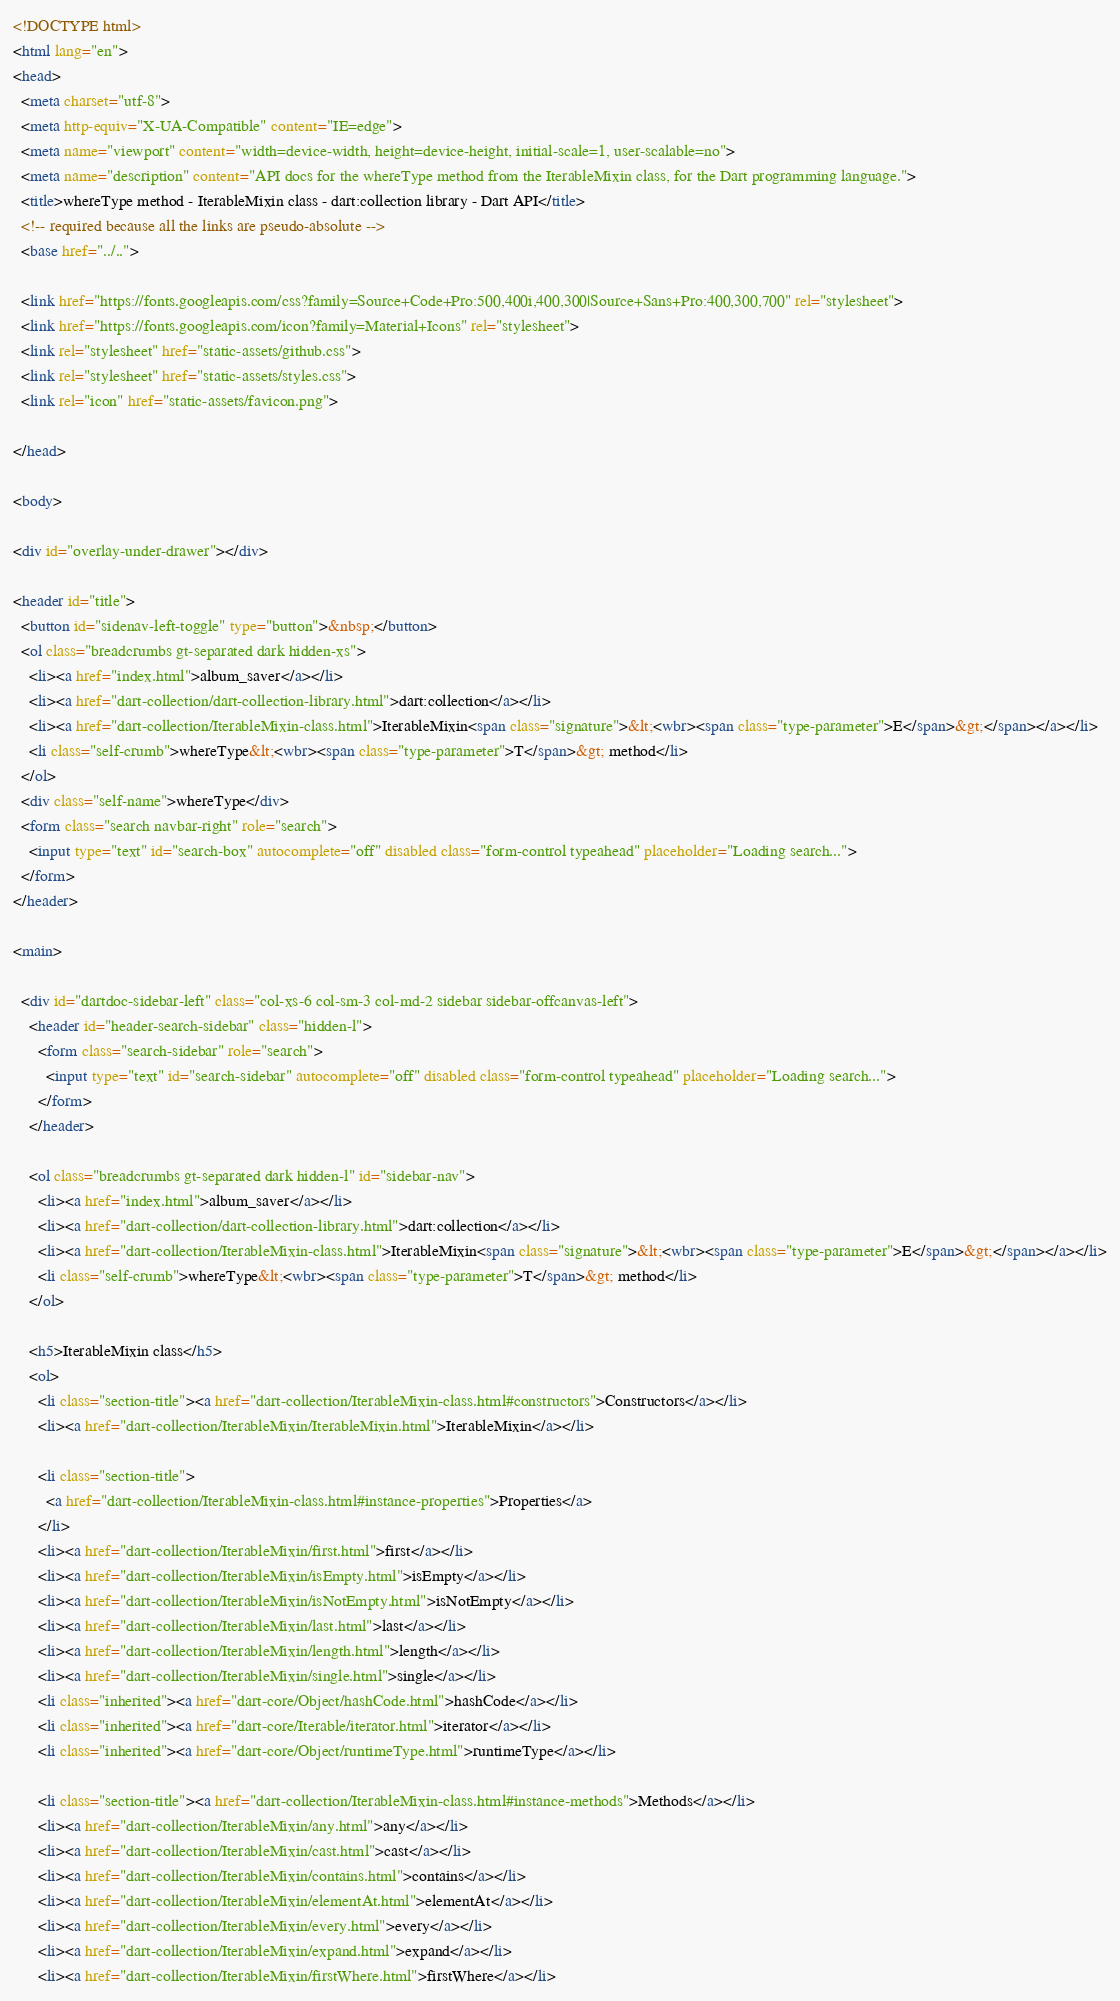<code> <loc_0><loc_0><loc_500><loc_500><_HTML_><!DOCTYPE html>
<html lang="en">
<head>
  <meta charset="utf-8">
  <meta http-equiv="X-UA-Compatible" content="IE=edge">
  <meta name="viewport" content="width=device-width, height=device-height, initial-scale=1, user-scalable=no">
  <meta name="description" content="API docs for the whereType method from the IterableMixin class, for the Dart programming language.">
  <title>whereType method - IterableMixin class - dart:collection library - Dart API</title>
  <!-- required because all the links are pseudo-absolute -->
  <base href="../..">

  <link href="https://fonts.googleapis.com/css?family=Source+Code+Pro:500,400i,400,300|Source+Sans+Pro:400,300,700" rel="stylesheet">
  <link href="https://fonts.googleapis.com/icon?family=Material+Icons" rel="stylesheet">
  <link rel="stylesheet" href="static-assets/github.css">
  <link rel="stylesheet" href="static-assets/styles.css">
  <link rel="icon" href="static-assets/favicon.png">
  
</head>

<body>

<div id="overlay-under-drawer"></div>

<header id="title">
  <button id="sidenav-left-toggle" type="button">&nbsp;</button>
  <ol class="breadcrumbs gt-separated dark hidden-xs">
    <li><a href="index.html">album_saver</a></li>
    <li><a href="dart-collection/dart-collection-library.html">dart:collection</a></li>
    <li><a href="dart-collection/IterableMixin-class.html">IterableMixin<span class="signature">&lt;<wbr><span class="type-parameter">E</span>&gt;</span></a></li>
    <li class="self-crumb">whereType&lt;<wbr><span class="type-parameter">T</span>&gt; method</li>
  </ol>
  <div class="self-name">whereType</div>
  <form class="search navbar-right" role="search">
    <input type="text" id="search-box" autocomplete="off" disabled class="form-control typeahead" placeholder="Loading search...">
  </form>
</header>

<main>

  <div id="dartdoc-sidebar-left" class="col-xs-6 col-sm-3 col-md-2 sidebar sidebar-offcanvas-left">
    <header id="header-search-sidebar" class="hidden-l">
      <form class="search-sidebar" role="search">
        <input type="text" id="search-sidebar" autocomplete="off" disabled class="form-control typeahead" placeholder="Loading search...">
      </form>
    </header>
    
    <ol class="breadcrumbs gt-separated dark hidden-l" id="sidebar-nav">
      <li><a href="index.html">album_saver</a></li>
      <li><a href="dart-collection/dart-collection-library.html">dart:collection</a></li>
      <li><a href="dart-collection/IterableMixin-class.html">IterableMixin<span class="signature">&lt;<wbr><span class="type-parameter">E</span>&gt;</span></a></li>
      <li class="self-crumb">whereType&lt;<wbr><span class="type-parameter">T</span>&gt; method</li>
    </ol>
    
    <h5>IterableMixin class</h5>
    <ol>
      <li class="section-title"><a href="dart-collection/IterableMixin-class.html#constructors">Constructors</a></li>
      <li><a href="dart-collection/IterableMixin/IterableMixin.html">IterableMixin</a></li>
    
      <li class="section-title">
        <a href="dart-collection/IterableMixin-class.html#instance-properties">Properties</a>
      </li>
      <li><a href="dart-collection/IterableMixin/first.html">first</a></li>
      <li><a href="dart-collection/IterableMixin/isEmpty.html">isEmpty</a></li>
      <li><a href="dart-collection/IterableMixin/isNotEmpty.html">isNotEmpty</a></li>
      <li><a href="dart-collection/IterableMixin/last.html">last</a></li>
      <li><a href="dart-collection/IterableMixin/length.html">length</a></li>
      <li><a href="dart-collection/IterableMixin/single.html">single</a></li>
      <li class="inherited"><a href="dart-core/Object/hashCode.html">hashCode</a></li>
      <li class="inherited"><a href="dart-core/Iterable/iterator.html">iterator</a></li>
      <li class="inherited"><a href="dart-core/Object/runtimeType.html">runtimeType</a></li>
    
      <li class="section-title"><a href="dart-collection/IterableMixin-class.html#instance-methods">Methods</a></li>
      <li><a href="dart-collection/IterableMixin/any.html">any</a></li>
      <li><a href="dart-collection/IterableMixin/cast.html">cast</a></li>
      <li><a href="dart-collection/IterableMixin/contains.html">contains</a></li>
      <li><a href="dart-collection/IterableMixin/elementAt.html">elementAt</a></li>
      <li><a href="dart-collection/IterableMixin/every.html">every</a></li>
      <li><a href="dart-collection/IterableMixin/expand.html">expand</a></li>
      <li><a href="dart-collection/IterableMixin/firstWhere.html">firstWhere</a></li></code> 